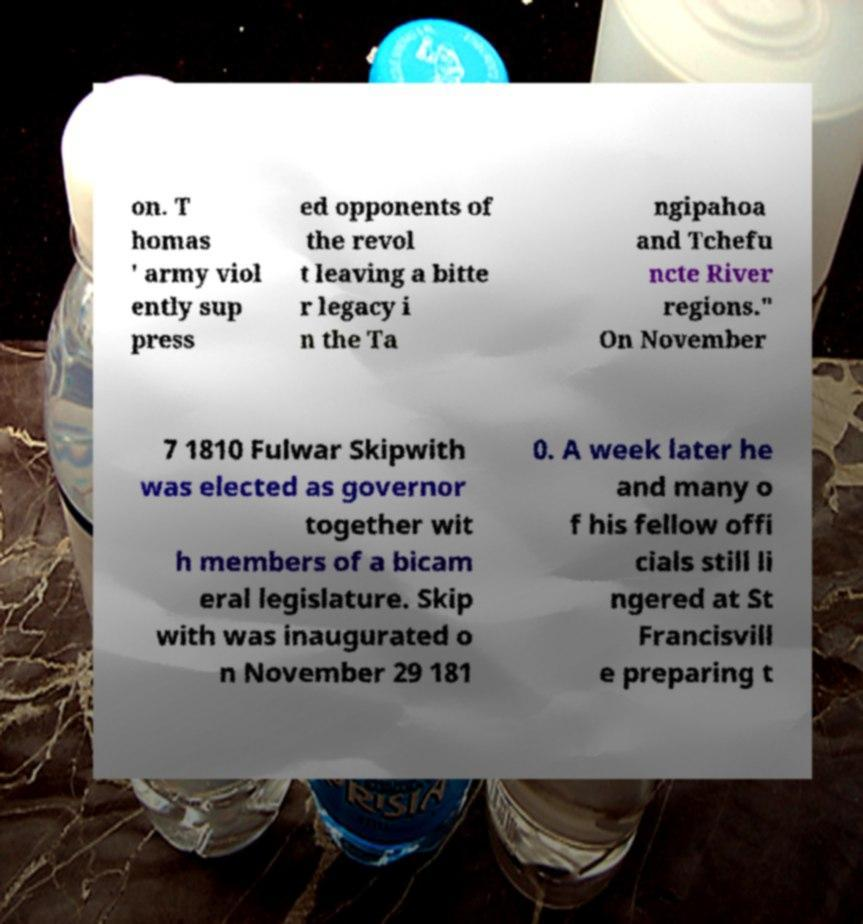There's text embedded in this image that I need extracted. Can you transcribe it verbatim? on. T homas ' army viol ently sup press ed opponents of the revol t leaving a bitte r legacy i n the Ta ngipahoa and Tchefu ncte River regions." On November 7 1810 Fulwar Skipwith was elected as governor together wit h members of a bicam eral legislature. Skip with was inaugurated o n November 29 181 0. A week later he and many o f his fellow offi cials still li ngered at St Francisvill e preparing t 